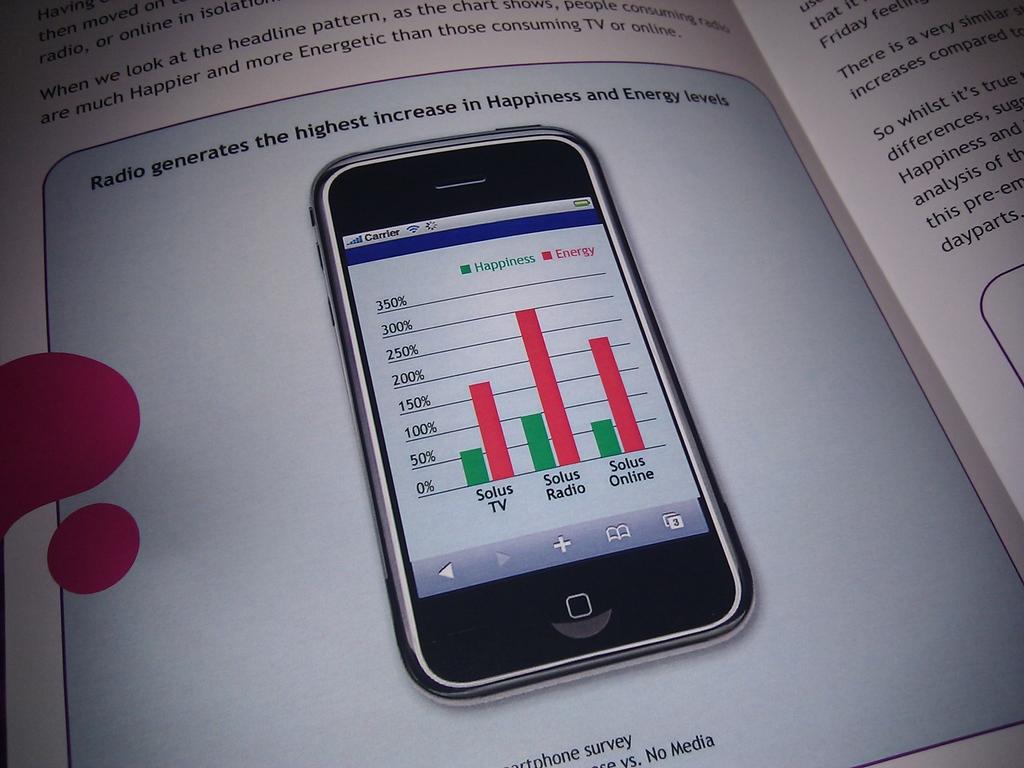What brand has the most energy?
Offer a very short reply. Solus radio. What does it say the radio generates?
Make the answer very short. The highest increase in happiness and energy levels. 